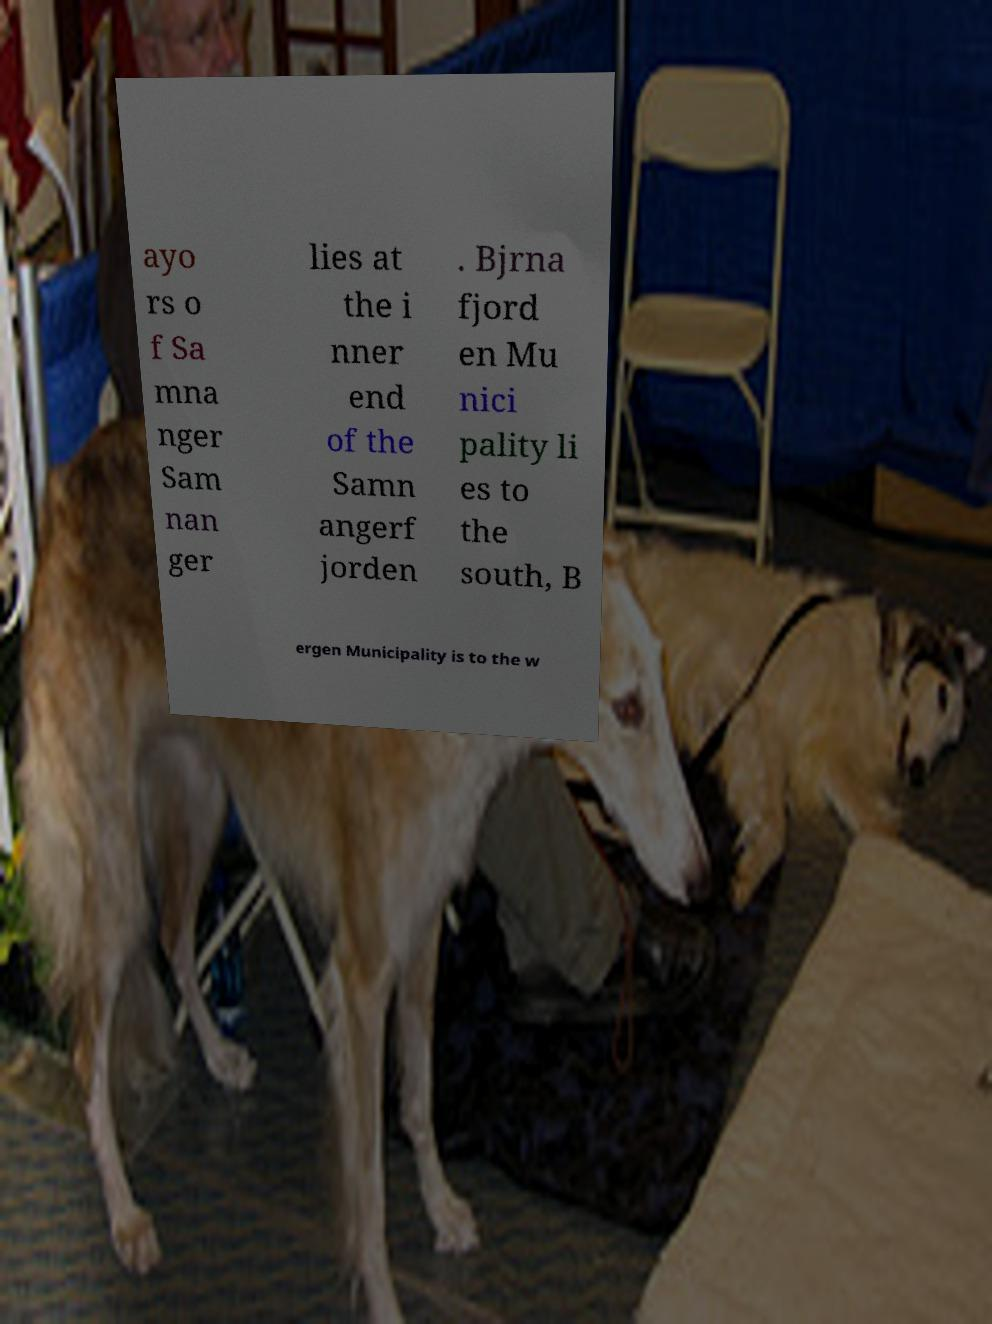There's text embedded in this image that I need extracted. Can you transcribe it verbatim? ayo rs o f Sa mna nger Sam nan ger lies at the i nner end of the Samn angerf jorden . Bjrna fjord en Mu nici pality li es to the south, B ergen Municipality is to the w 